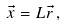<formula> <loc_0><loc_0><loc_500><loc_500>\vec { x } = L \vec { r } \, ,</formula> 